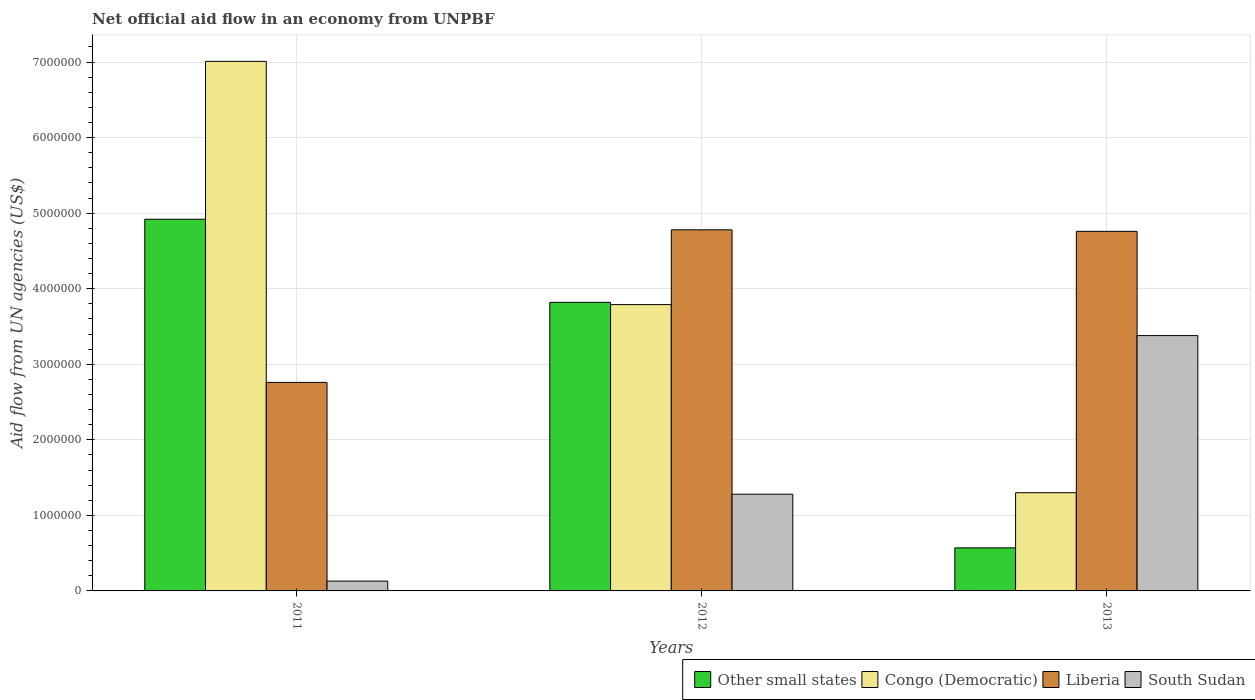How many different coloured bars are there?
Your answer should be very brief. 4. How many groups of bars are there?
Your answer should be compact. 3. Are the number of bars per tick equal to the number of legend labels?
Your response must be concise. Yes. How many bars are there on the 2nd tick from the right?
Make the answer very short. 4. What is the net official aid flow in Congo (Democratic) in 2011?
Ensure brevity in your answer.  7.01e+06. Across all years, what is the maximum net official aid flow in Other small states?
Make the answer very short. 4.92e+06. Across all years, what is the minimum net official aid flow in Congo (Democratic)?
Your answer should be very brief. 1.30e+06. In which year was the net official aid flow in Congo (Democratic) maximum?
Offer a very short reply. 2011. In which year was the net official aid flow in Other small states minimum?
Ensure brevity in your answer.  2013. What is the total net official aid flow in Congo (Democratic) in the graph?
Provide a succinct answer. 1.21e+07. What is the difference between the net official aid flow in Other small states in 2012 and the net official aid flow in Liberia in 2013?
Your answer should be very brief. -9.40e+05. What is the average net official aid flow in Other small states per year?
Your response must be concise. 3.10e+06. In the year 2013, what is the difference between the net official aid flow in Liberia and net official aid flow in Congo (Democratic)?
Offer a very short reply. 3.46e+06. In how many years, is the net official aid flow in South Sudan greater than 4400000 US$?
Your answer should be compact. 0. What is the ratio of the net official aid flow in Congo (Democratic) in 2011 to that in 2013?
Your response must be concise. 5.39. What is the difference between the highest and the second highest net official aid flow in Other small states?
Provide a short and direct response. 1.10e+06. What is the difference between the highest and the lowest net official aid flow in Other small states?
Offer a very short reply. 4.35e+06. What does the 4th bar from the left in 2013 represents?
Your response must be concise. South Sudan. What does the 3rd bar from the right in 2013 represents?
Provide a succinct answer. Congo (Democratic). Is it the case that in every year, the sum of the net official aid flow in Other small states and net official aid flow in Congo (Democratic) is greater than the net official aid flow in Liberia?
Keep it short and to the point. No. How many bars are there?
Offer a terse response. 12. Does the graph contain any zero values?
Make the answer very short. No. How many legend labels are there?
Your response must be concise. 4. What is the title of the graph?
Offer a terse response. Net official aid flow in an economy from UNPBF. What is the label or title of the X-axis?
Provide a succinct answer. Years. What is the label or title of the Y-axis?
Provide a short and direct response. Aid flow from UN agencies (US$). What is the Aid flow from UN agencies (US$) in Other small states in 2011?
Give a very brief answer. 4.92e+06. What is the Aid flow from UN agencies (US$) in Congo (Democratic) in 2011?
Your answer should be compact. 7.01e+06. What is the Aid flow from UN agencies (US$) of Liberia in 2011?
Offer a very short reply. 2.76e+06. What is the Aid flow from UN agencies (US$) of Other small states in 2012?
Give a very brief answer. 3.82e+06. What is the Aid flow from UN agencies (US$) in Congo (Democratic) in 2012?
Your answer should be compact. 3.79e+06. What is the Aid flow from UN agencies (US$) in Liberia in 2012?
Ensure brevity in your answer.  4.78e+06. What is the Aid flow from UN agencies (US$) of South Sudan in 2012?
Give a very brief answer. 1.28e+06. What is the Aid flow from UN agencies (US$) of Other small states in 2013?
Ensure brevity in your answer.  5.70e+05. What is the Aid flow from UN agencies (US$) of Congo (Democratic) in 2013?
Your answer should be very brief. 1.30e+06. What is the Aid flow from UN agencies (US$) in Liberia in 2013?
Make the answer very short. 4.76e+06. What is the Aid flow from UN agencies (US$) in South Sudan in 2013?
Keep it short and to the point. 3.38e+06. Across all years, what is the maximum Aid flow from UN agencies (US$) of Other small states?
Your answer should be very brief. 4.92e+06. Across all years, what is the maximum Aid flow from UN agencies (US$) of Congo (Democratic)?
Offer a terse response. 7.01e+06. Across all years, what is the maximum Aid flow from UN agencies (US$) of Liberia?
Keep it short and to the point. 4.78e+06. Across all years, what is the maximum Aid flow from UN agencies (US$) in South Sudan?
Give a very brief answer. 3.38e+06. Across all years, what is the minimum Aid flow from UN agencies (US$) of Other small states?
Give a very brief answer. 5.70e+05. Across all years, what is the minimum Aid flow from UN agencies (US$) in Congo (Democratic)?
Provide a succinct answer. 1.30e+06. Across all years, what is the minimum Aid flow from UN agencies (US$) in Liberia?
Provide a succinct answer. 2.76e+06. Across all years, what is the minimum Aid flow from UN agencies (US$) in South Sudan?
Provide a short and direct response. 1.30e+05. What is the total Aid flow from UN agencies (US$) in Other small states in the graph?
Your answer should be very brief. 9.31e+06. What is the total Aid flow from UN agencies (US$) in Congo (Democratic) in the graph?
Your response must be concise. 1.21e+07. What is the total Aid flow from UN agencies (US$) of Liberia in the graph?
Provide a succinct answer. 1.23e+07. What is the total Aid flow from UN agencies (US$) in South Sudan in the graph?
Your answer should be compact. 4.79e+06. What is the difference between the Aid flow from UN agencies (US$) in Other small states in 2011 and that in 2012?
Your answer should be compact. 1.10e+06. What is the difference between the Aid flow from UN agencies (US$) of Congo (Democratic) in 2011 and that in 2012?
Your answer should be very brief. 3.22e+06. What is the difference between the Aid flow from UN agencies (US$) in Liberia in 2011 and that in 2012?
Keep it short and to the point. -2.02e+06. What is the difference between the Aid flow from UN agencies (US$) in South Sudan in 2011 and that in 2012?
Offer a very short reply. -1.15e+06. What is the difference between the Aid flow from UN agencies (US$) in Other small states in 2011 and that in 2013?
Offer a very short reply. 4.35e+06. What is the difference between the Aid flow from UN agencies (US$) in Congo (Democratic) in 2011 and that in 2013?
Make the answer very short. 5.71e+06. What is the difference between the Aid flow from UN agencies (US$) of South Sudan in 2011 and that in 2013?
Keep it short and to the point. -3.25e+06. What is the difference between the Aid flow from UN agencies (US$) in Other small states in 2012 and that in 2013?
Offer a terse response. 3.25e+06. What is the difference between the Aid flow from UN agencies (US$) of Congo (Democratic) in 2012 and that in 2013?
Ensure brevity in your answer.  2.49e+06. What is the difference between the Aid flow from UN agencies (US$) of Liberia in 2012 and that in 2013?
Offer a terse response. 2.00e+04. What is the difference between the Aid flow from UN agencies (US$) of South Sudan in 2012 and that in 2013?
Your answer should be compact. -2.10e+06. What is the difference between the Aid flow from UN agencies (US$) in Other small states in 2011 and the Aid flow from UN agencies (US$) in Congo (Democratic) in 2012?
Offer a terse response. 1.13e+06. What is the difference between the Aid flow from UN agencies (US$) of Other small states in 2011 and the Aid flow from UN agencies (US$) of South Sudan in 2012?
Offer a very short reply. 3.64e+06. What is the difference between the Aid flow from UN agencies (US$) in Congo (Democratic) in 2011 and the Aid flow from UN agencies (US$) in Liberia in 2012?
Your answer should be compact. 2.23e+06. What is the difference between the Aid flow from UN agencies (US$) in Congo (Democratic) in 2011 and the Aid flow from UN agencies (US$) in South Sudan in 2012?
Ensure brevity in your answer.  5.73e+06. What is the difference between the Aid flow from UN agencies (US$) of Liberia in 2011 and the Aid flow from UN agencies (US$) of South Sudan in 2012?
Provide a short and direct response. 1.48e+06. What is the difference between the Aid flow from UN agencies (US$) of Other small states in 2011 and the Aid flow from UN agencies (US$) of Congo (Democratic) in 2013?
Ensure brevity in your answer.  3.62e+06. What is the difference between the Aid flow from UN agencies (US$) in Other small states in 2011 and the Aid flow from UN agencies (US$) in South Sudan in 2013?
Make the answer very short. 1.54e+06. What is the difference between the Aid flow from UN agencies (US$) in Congo (Democratic) in 2011 and the Aid flow from UN agencies (US$) in Liberia in 2013?
Offer a very short reply. 2.25e+06. What is the difference between the Aid flow from UN agencies (US$) of Congo (Democratic) in 2011 and the Aid flow from UN agencies (US$) of South Sudan in 2013?
Your response must be concise. 3.63e+06. What is the difference between the Aid flow from UN agencies (US$) in Liberia in 2011 and the Aid flow from UN agencies (US$) in South Sudan in 2013?
Offer a terse response. -6.20e+05. What is the difference between the Aid flow from UN agencies (US$) of Other small states in 2012 and the Aid flow from UN agencies (US$) of Congo (Democratic) in 2013?
Your answer should be compact. 2.52e+06. What is the difference between the Aid flow from UN agencies (US$) of Other small states in 2012 and the Aid flow from UN agencies (US$) of Liberia in 2013?
Your answer should be very brief. -9.40e+05. What is the difference between the Aid flow from UN agencies (US$) in Congo (Democratic) in 2012 and the Aid flow from UN agencies (US$) in Liberia in 2013?
Make the answer very short. -9.70e+05. What is the difference between the Aid flow from UN agencies (US$) of Congo (Democratic) in 2012 and the Aid flow from UN agencies (US$) of South Sudan in 2013?
Provide a succinct answer. 4.10e+05. What is the difference between the Aid flow from UN agencies (US$) in Liberia in 2012 and the Aid flow from UN agencies (US$) in South Sudan in 2013?
Your answer should be very brief. 1.40e+06. What is the average Aid flow from UN agencies (US$) in Other small states per year?
Offer a very short reply. 3.10e+06. What is the average Aid flow from UN agencies (US$) of Congo (Democratic) per year?
Make the answer very short. 4.03e+06. What is the average Aid flow from UN agencies (US$) of Liberia per year?
Your answer should be compact. 4.10e+06. What is the average Aid flow from UN agencies (US$) in South Sudan per year?
Your answer should be very brief. 1.60e+06. In the year 2011, what is the difference between the Aid flow from UN agencies (US$) in Other small states and Aid flow from UN agencies (US$) in Congo (Democratic)?
Offer a very short reply. -2.09e+06. In the year 2011, what is the difference between the Aid flow from UN agencies (US$) of Other small states and Aid flow from UN agencies (US$) of Liberia?
Your response must be concise. 2.16e+06. In the year 2011, what is the difference between the Aid flow from UN agencies (US$) in Other small states and Aid flow from UN agencies (US$) in South Sudan?
Your answer should be compact. 4.79e+06. In the year 2011, what is the difference between the Aid flow from UN agencies (US$) of Congo (Democratic) and Aid flow from UN agencies (US$) of Liberia?
Keep it short and to the point. 4.25e+06. In the year 2011, what is the difference between the Aid flow from UN agencies (US$) of Congo (Democratic) and Aid flow from UN agencies (US$) of South Sudan?
Provide a short and direct response. 6.88e+06. In the year 2011, what is the difference between the Aid flow from UN agencies (US$) in Liberia and Aid flow from UN agencies (US$) in South Sudan?
Your response must be concise. 2.63e+06. In the year 2012, what is the difference between the Aid flow from UN agencies (US$) of Other small states and Aid flow from UN agencies (US$) of Liberia?
Offer a very short reply. -9.60e+05. In the year 2012, what is the difference between the Aid flow from UN agencies (US$) in Other small states and Aid flow from UN agencies (US$) in South Sudan?
Ensure brevity in your answer.  2.54e+06. In the year 2012, what is the difference between the Aid flow from UN agencies (US$) in Congo (Democratic) and Aid flow from UN agencies (US$) in Liberia?
Offer a very short reply. -9.90e+05. In the year 2012, what is the difference between the Aid flow from UN agencies (US$) of Congo (Democratic) and Aid flow from UN agencies (US$) of South Sudan?
Provide a succinct answer. 2.51e+06. In the year 2012, what is the difference between the Aid flow from UN agencies (US$) of Liberia and Aid flow from UN agencies (US$) of South Sudan?
Give a very brief answer. 3.50e+06. In the year 2013, what is the difference between the Aid flow from UN agencies (US$) in Other small states and Aid flow from UN agencies (US$) in Congo (Democratic)?
Provide a short and direct response. -7.30e+05. In the year 2013, what is the difference between the Aid flow from UN agencies (US$) in Other small states and Aid flow from UN agencies (US$) in Liberia?
Your answer should be compact. -4.19e+06. In the year 2013, what is the difference between the Aid flow from UN agencies (US$) of Other small states and Aid flow from UN agencies (US$) of South Sudan?
Your answer should be very brief. -2.81e+06. In the year 2013, what is the difference between the Aid flow from UN agencies (US$) of Congo (Democratic) and Aid flow from UN agencies (US$) of Liberia?
Ensure brevity in your answer.  -3.46e+06. In the year 2013, what is the difference between the Aid flow from UN agencies (US$) in Congo (Democratic) and Aid flow from UN agencies (US$) in South Sudan?
Your response must be concise. -2.08e+06. In the year 2013, what is the difference between the Aid flow from UN agencies (US$) of Liberia and Aid flow from UN agencies (US$) of South Sudan?
Provide a succinct answer. 1.38e+06. What is the ratio of the Aid flow from UN agencies (US$) in Other small states in 2011 to that in 2012?
Offer a terse response. 1.29. What is the ratio of the Aid flow from UN agencies (US$) in Congo (Democratic) in 2011 to that in 2012?
Provide a succinct answer. 1.85. What is the ratio of the Aid flow from UN agencies (US$) in Liberia in 2011 to that in 2012?
Your answer should be very brief. 0.58. What is the ratio of the Aid flow from UN agencies (US$) of South Sudan in 2011 to that in 2012?
Your answer should be compact. 0.1. What is the ratio of the Aid flow from UN agencies (US$) of Other small states in 2011 to that in 2013?
Give a very brief answer. 8.63. What is the ratio of the Aid flow from UN agencies (US$) of Congo (Democratic) in 2011 to that in 2013?
Provide a succinct answer. 5.39. What is the ratio of the Aid flow from UN agencies (US$) of Liberia in 2011 to that in 2013?
Your answer should be compact. 0.58. What is the ratio of the Aid flow from UN agencies (US$) of South Sudan in 2011 to that in 2013?
Give a very brief answer. 0.04. What is the ratio of the Aid flow from UN agencies (US$) of Other small states in 2012 to that in 2013?
Provide a short and direct response. 6.7. What is the ratio of the Aid flow from UN agencies (US$) of Congo (Democratic) in 2012 to that in 2013?
Offer a terse response. 2.92. What is the ratio of the Aid flow from UN agencies (US$) in Liberia in 2012 to that in 2013?
Give a very brief answer. 1. What is the ratio of the Aid flow from UN agencies (US$) in South Sudan in 2012 to that in 2013?
Your answer should be compact. 0.38. What is the difference between the highest and the second highest Aid flow from UN agencies (US$) in Other small states?
Give a very brief answer. 1.10e+06. What is the difference between the highest and the second highest Aid flow from UN agencies (US$) of Congo (Democratic)?
Give a very brief answer. 3.22e+06. What is the difference between the highest and the second highest Aid flow from UN agencies (US$) in Liberia?
Your answer should be compact. 2.00e+04. What is the difference between the highest and the second highest Aid flow from UN agencies (US$) in South Sudan?
Provide a short and direct response. 2.10e+06. What is the difference between the highest and the lowest Aid flow from UN agencies (US$) in Other small states?
Your answer should be compact. 4.35e+06. What is the difference between the highest and the lowest Aid flow from UN agencies (US$) of Congo (Democratic)?
Ensure brevity in your answer.  5.71e+06. What is the difference between the highest and the lowest Aid flow from UN agencies (US$) of Liberia?
Give a very brief answer. 2.02e+06. What is the difference between the highest and the lowest Aid flow from UN agencies (US$) of South Sudan?
Offer a terse response. 3.25e+06. 